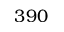<formula> <loc_0><loc_0><loc_500><loc_500>3 9 0</formula> 